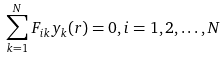Convert formula to latex. <formula><loc_0><loc_0><loc_500><loc_500>\sum _ { k = 1 } ^ { N } F _ { i k } y _ { k } ( r ) = 0 , i = 1 , 2 , \dots , N</formula> 